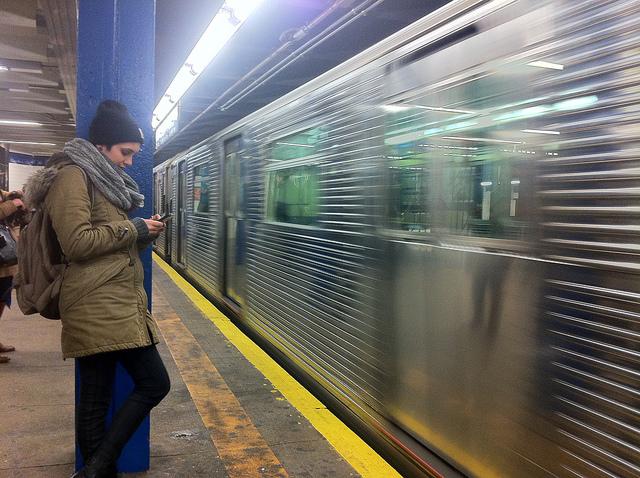Is this person using a cell phone?
Give a very brief answer. Yes. What type of transit is shown in this picture?
Answer briefly. Subway. What is the color of the train?
Short answer required. Silver. 